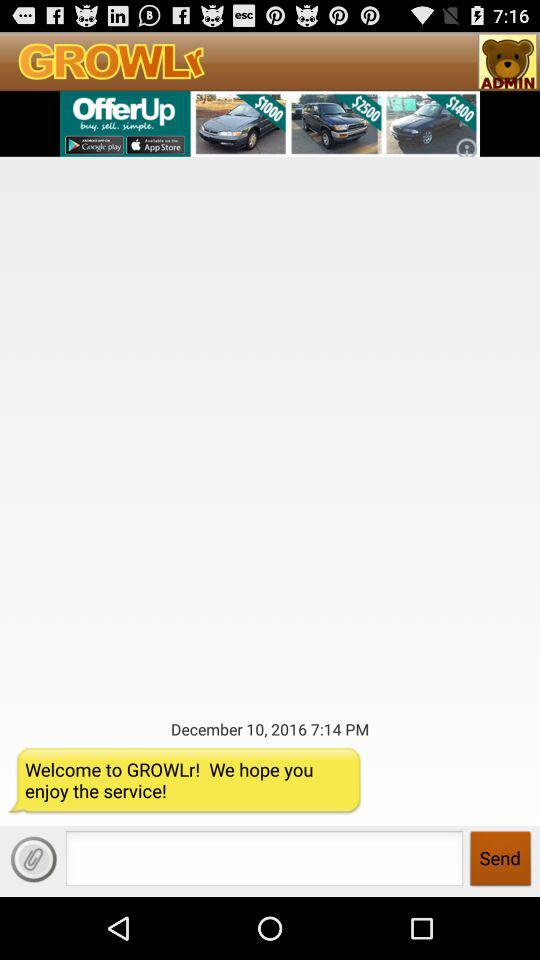What is the message displayed on the screen? The displayed message is "Welcome to GROWLr! We hope you enjoy the service!". 